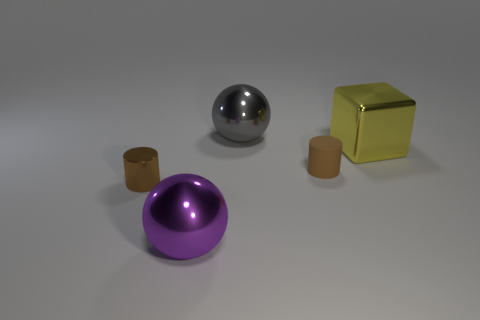How many other things are there of the same shape as the yellow object?
Offer a terse response. 0. There is a shiny block; what number of large metal spheres are behind it?
Provide a short and direct response. 1. There is a metal object that is both in front of the yellow metallic object and behind the purple ball; how big is it?
Provide a short and direct response. Small. Are there any small matte objects?
Keep it short and to the point. Yes. What number of other things are there of the same size as the rubber cylinder?
Give a very brief answer. 1. Is the color of the tiny object that is on the left side of the large purple shiny thing the same as the small cylinder on the right side of the purple object?
Give a very brief answer. Yes. There is another object that is the same shape as the tiny rubber object; what size is it?
Your answer should be very brief. Small. Are the small cylinder that is to the right of the big purple object and the big ball that is behind the large yellow cube made of the same material?
Your answer should be very brief. No. What number of metal things are blue cylinders or yellow blocks?
Make the answer very short. 1. The small brown cylinder right of the big sphere that is behind the small brown metallic object that is on the left side of the gray thing is made of what material?
Ensure brevity in your answer.  Rubber. 